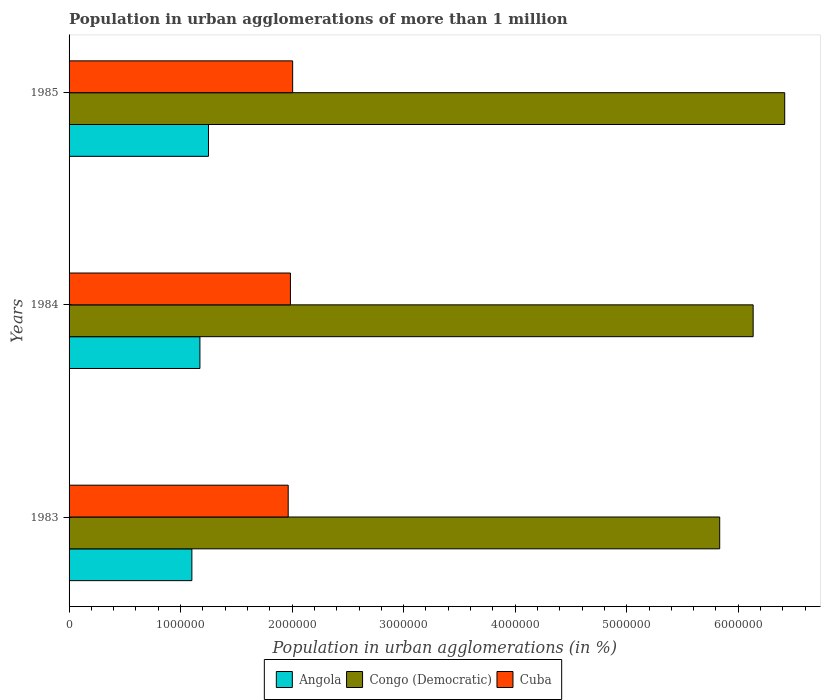How many different coloured bars are there?
Provide a succinct answer. 3. How many bars are there on the 3rd tick from the top?
Your answer should be compact. 3. How many bars are there on the 2nd tick from the bottom?
Your answer should be compact. 3. What is the label of the 1st group of bars from the top?
Give a very brief answer. 1985. In how many cases, is the number of bars for a given year not equal to the number of legend labels?
Your response must be concise. 0. What is the population in urban agglomerations in Cuba in 1984?
Provide a succinct answer. 1.98e+06. Across all years, what is the maximum population in urban agglomerations in Congo (Democratic)?
Your answer should be very brief. 6.42e+06. Across all years, what is the minimum population in urban agglomerations in Cuba?
Make the answer very short. 1.96e+06. What is the total population in urban agglomerations in Congo (Democratic) in the graph?
Provide a short and direct response. 1.84e+07. What is the difference between the population in urban agglomerations in Cuba in 1984 and that in 1985?
Provide a short and direct response. -2.01e+04. What is the difference between the population in urban agglomerations in Congo (Democratic) in 1985 and the population in urban agglomerations in Angola in 1984?
Ensure brevity in your answer.  5.24e+06. What is the average population in urban agglomerations in Congo (Democratic) per year?
Your answer should be very brief. 6.13e+06. In the year 1984, what is the difference between the population in urban agglomerations in Angola and population in urban agglomerations in Congo (Democratic)?
Provide a succinct answer. -4.96e+06. What is the ratio of the population in urban agglomerations in Cuba in 1983 to that in 1985?
Give a very brief answer. 0.98. Is the population in urban agglomerations in Cuba in 1983 less than that in 1985?
Your answer should be very brief. Yes. Is the difference between the population in urban agglomerations in Angola in 1983 and 1984 greater than the difference between the population in urban agglomerations in Congo (Democratic) in 1983 and 1984?
Provide a short and direct response. Yes. What is the difference between the highest and the second highest population in urban agglomerations in Angola?
Your answer should be compact. 7.67e+04. What is the difference between the highest and the lowest population in urban agglomerations in Cuba?
Offer a very short reply. 4.00e+04. What does the 2nd bar from the top in 1984 represents?
Keep it short and to the point. Congo (Democratic). What does the 3rd bar from the bottom in 1984 represents?
Give a very brief answer. Cuba. Is it the case that in every year, the sum of the population in urban agglomerations in Congo (Democratic) and population in urban agglomerations in Angola is greater than the population in urban agglomerations in Cuba?
Provide a succinct answer. Yes. Are all the bars in the graph horizontal?
Provide a short and direct response. Yes. How many years are there in the graph?
Keep it short and to the point. 3. How many legend labels are there?
Keep it short and to the point. 3. What is the title of the graph?
Offer a terse response. Population in urban agglomerations of more than 1 million. Does "Liberia" appear as one of the legend labels in the graph?
Your response must be concise. No. What is the label or title of the X-axis?
Offer a very short reply. Population in urban agglomerations (in %). What is the label or title of the Y-axis?
Your answer should be compact. Years. What is the Population in urban agglomerations (in %) in Angola in 1983?
Give a very brief answer. 1.10e+06. What is the Population in urban agglomerations (in %) of Congo (Democratic) in 1983?
Your answer should be compact. 5.83e+06. What is the Population in urban agglomerations (in %) of Cuba in 1983?
Provide a succinct answer. 1.96e+06. What is the Population in urban agglomerations (in %) in Angola in 1984?
Your response must be concise. 1.17e+06. What is the Population in urban agglomerations (in %) in Congo (Democratic) in 1984?
Your answer should be compact. 6.13e+06. What is the Population in urban agglomerations (in %) of Cuba in 1984?
Your answer should be very brief. 1.98e+06. What is the Population in urban agglomerations (in %) of Angola in 1985?
Offer a terse response. 1.25e+06. What is the Population in urban agglomerations (in %) of Congo (Democratic) in 1985?
Give a very brief answer. 6.42e+06. What is the Population in urban agglomerations (in %) of Cuba in 1985?
Offer a very short reply. 2.00e+06. Across all years, what is the maximum Population in urban agglomerations (in %) in Angola?
Provide a succinct answer. 1.25e+06. Across all years, what is the maximum Population in urban agglomerations (in %) in Congo (Democratic)?
Your response must be concise. 6.42e+06. Across all years, what is the maximum Population in urban agglomerations (in %) of Cuba?
Ensure brevity in your answer.  2.00e+06. Across all years, what is the minimum Population in urban agglomerations (in %) in Angola?
Your answer should be very brief. 1.10e+06. Across all years, what is the minimum Population in urban agglomerations (in %) of Congo (Democratic)?
Give a very brief answer. 5.83e+06. Across all years, what is the minimum Population in urban agglomerations (in %) in Cuba?
Your answer should be compact. 1.96e+06. What is the total Population in urban agglomerations (in %) in Angola in the graph?
Your response must be concise. 3.52e+06. What is the total Population in urban agglomerations (in %) in Congo (Democratic) in the graph?
Keep it short and to the point. 1.84e+07. What is the total Population in urban agglomerations (in %) in Cuba in the graph?
Make the answer very short. 5.95e+06. What is the difference between the Population in urban agglomerations (in %) in Angola in 1983 and that in 1984?
Make the answer very short. -7.22e+04. What is the difference between the Population in urban agglomerations (in %) of Congo (Democratic) in 1983 and that in 1984?
Make the answer very short. -3.00e+05. What is the difference between the Population in urban agglomerations (in %) in Cuba in 1983 and that in 1984?
Provide a succinct answer. -1.99e+04. What is the difference between the Population in urban agglomerations (in %) in Angola in 1983 and that in 1985?
Your response must be concise. -1.49e+05. What is the difference between the Population in urban agglomerations (in %) in Congo (Democratic) in 1983 and that in 1985?
Your answer should be very brief. -5.83e+05. What is the difference between the Population in urban agglomerations (in %) in Cuba in 1983 and that in 1985?
Keep it short and to the point. -4.00e+04. What is the difference between the Population in urban agglomerations (in %) in Angola in 1984 and that in 1985?
Your answer should be compact. -7.67e+04. What is the difference between the Population in urban agglomerations (in %) in Congo (Democratic) in 1984 and that in 1985?
Provide a short and direct response. -2.83e+05. What is the difference between the Population in urban agglomerations (in %) in Cuba in 1984 and that in 1985?
Make the answer very short. -2.01e+04. What is the difference between the Population in urban agglomerations (in %) of Angola in 1983 and the Population in urban agglomerations (in %) of Congo (Democratic) in 1984?
Your response must be concise. -5.03e+06. What is the difference between the Population in urban agglomerations (in %) of Angola in 1983 and the Population in urban agglomerations (in %) of Cuba in 1984?
Offer a terse response. -8.84e+05. What is the difference between the Population in urban agglomerations (in %) of Congo (Democratic) in 1983 and the Population in urban agglomerations (in %) of Cuba in 1984?
Offer a very short reply. 3.85e+06. What is the difference between the Population in urban agglomerations (in %) in Angola in 1983 and the Population in urban agglomerations (in %) in Congo (Democratic) in 1985?
Make the answer very short. -5.32e+06. What is the difference between the Population in urban agglomerations (in %) of Angola in 1983 and the Population in urban agglomerations (in %) of Cuba in 1985?
Your response must be concise. -9.04e+05. What is the difference between the Population in urban agglomerations (in %) in Congo (Democratic) in 1983 and the Population in urban agglomerations (in %) in Cuba in 1985?
Ensure brevity in your answer.  3.83e+06. What is the difference between the Population in urban agglomerations (in %) of Angola in 1984 and the Population in urban agglomerations (in %) of Congo (Democratic) in 1985?
Provide a succinct answer. -5.24e+06. What is the difference between the Population in urban agglomerations (in %) of Angola in 1984 and the Population in urban agglomerations (in %) of Cuba in 1985?
Make the answer very short. -8.31e+05. What is the difference between the Population in urban agglomerations (in %) of Congo (Democratic) in 1984 and the Population in urban agglomerations (in %) of Cuba in 1985?
Provide a short and direct response. 4.13e+06. What is the average Population in urban agglomerations (in %) in Angola per year?
Provide a succinct answer. 1.17e+06. What is the average Population in urban agglomerations (in %) in Congo (Democratic) per year?
Give a very brief answer. 6.13e+06. What is the average Population in urban agglomerations (in %) in Cuba per year?
Your response must be concise. 1.98e+06. In the year 1983, what is the difference between the Population in urban agglomerations (in %) of Angola and Population in urban agglomerations (in %) of Congo (Democratic)?
Make the answer very short. -4.73e+06. In the year 1983, what is the difference between the Population in urban agglomerations (in %) in Angola and Population in urban agglomerations (in %) in Cuba?
Provide a short and direct response. -8.64e+05. In the year 1983, what is the difference between the Population in urban agglomerations (in %) in Congo (Democratic) and Population in urban agglomerations (in %) in Cuba?
Offer a very short reply. 3.87e+06. In the year 1984, what is the difference between the Population in urban agglomerations (in %) in Angola and Population in urban agglomerations (in %) in Congo (Democratic)?
Your response must be concise. -4.96e+06. In the year 1984, what is the difference between the Population in urban agglomerations (in %) in Angola and Population in urban agglomerations (in %) in Cuba?
Your answer should be very brief. -8.11e+05. In the year 1984, what is the difference between the Population in urban agglomerations (in %) in Congo (Democratic) and Population in urban agglomerations (in %) in Cuba?
Your response must be concise. 4.15e+06. In the year 1985, what is the difference between the Population in urban agglomerations (in %) of Angola and Population in urban agglomerations (in %) of Congo (Democratic)?
Offer a terse response. -5.17e+06. In the year 1985, what is the difference between the Population in urban agglomerations (in %) in Angola and Population in urban agglomerations (in %) in Cuba?
Offer a very short reply. -7.55e+05. In the year 1985, what is the difference between the Population in urban agglomerations (in %) in Congo (Democratic) and Population in urban agglomerations (in %) in Cuba?
Ensure brevity in your answer.  4.41e+06. What is the ratio of the Population in urban agglomerations (in %) in Angola in 1983 to that in 1984?
Your answer should be compact. 0.94. What is the ratio of the Population in urban agglomerations (in %) of Congo (Democratic) in 1983 to that in 1984?
Provide a short and direct response. 0.95. What is the ratio of the Population in urban agglomerations (in %) of Angola in 1983 to that in 1985?
Offer a terse response. 0.88. What is the ratio of the Population in urban agglomerations (in %) of Congo (Democratic) in 1983 to that in 1985?
Provide a short and direct response. 0.91. What is the ratio of the Population in urban agglomerations (in %) in Cuba in 1983 to that in 1985?
Your answer should be compact. 0.98. What is the ratio of the Population in urban agglomerations (in %) in Angola in 1984 to that in 1985?
Offer a very short reply. 0.94. What is the ratio of the Population in urban agglomerations (in %) in Congo (Democratic) in 1984 to that in 1985?
Your answer should be very brief. 0.96. What is the difference between the highest and the second highest Population in urban agglomerations (in %) of Angola?
Provide a short and direct response. 7.67e+04. What is the difference between the highest and the second highest Population in urban agglomerations (in %) in Congo (Democratic)?
Your answer should be very brief. 2.83e+05. What is the difference between the highest and the second highest Population in urban agglomerations (in %) in Cuba?
Provide a short and direct response. 2.01e+04. What is the difference between the highest and the lowest Population in urban agglomerations (in %) in Angola?
Offer a very short reply. 1.49e+05. What is the difference between the highest and the lowest Population in urban agglomerations (in %) of Congo (Democratic)?
Offer a terse response. 5.83e+05. What is the difference between the highest and the lowest Population in urban agglomerations (in %) of Cuba?
Your response must be concise. 4.00e+04. 